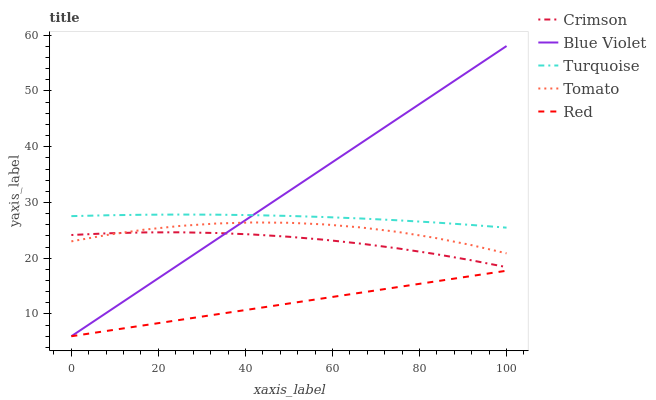Does Tomato have the minimum area under the curve?
Answer yes or no. No. Does Tomato have the maximum area under the curve?
Answer yes or no. No. Is Turquoise the smoothest?
Answer yes or no. No. Is Turquoise the roughest?
Answer yes or no. No. Does Tomato have the lowest value?
Answer yes or no. No. Does Tomato have the highest value?
Answer yes or no. No. Is Red less than Turquoise?
Answer yes or no. Yes. Is Turquoise greater than Red?
Answer yes or no. Yes. Does Red intersect Turquoise?
Answer yes or no. No. 